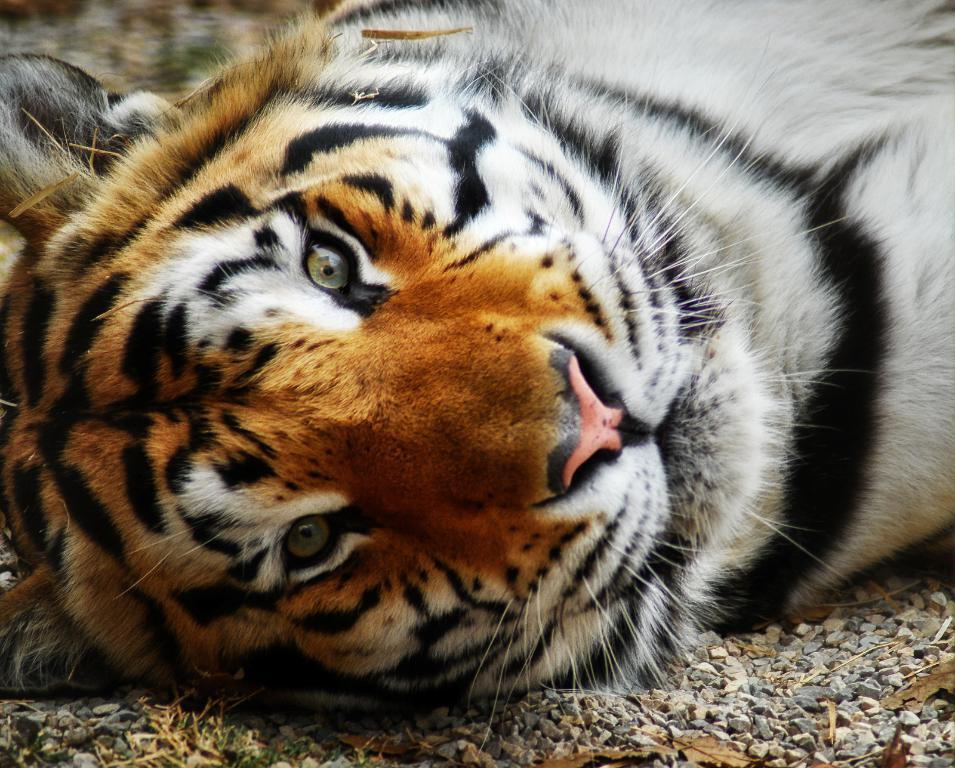What type of animal is in the image? There is a tiger in the image. Where is the tiger located? The tiger is on the ground. What other elements can be seen in the image? There are stones and leaves in the image. Who is the owner of the tiger in the image? There is no indication of an owner in the image, as it only shows a tiger on the ground with stones and leaves. 